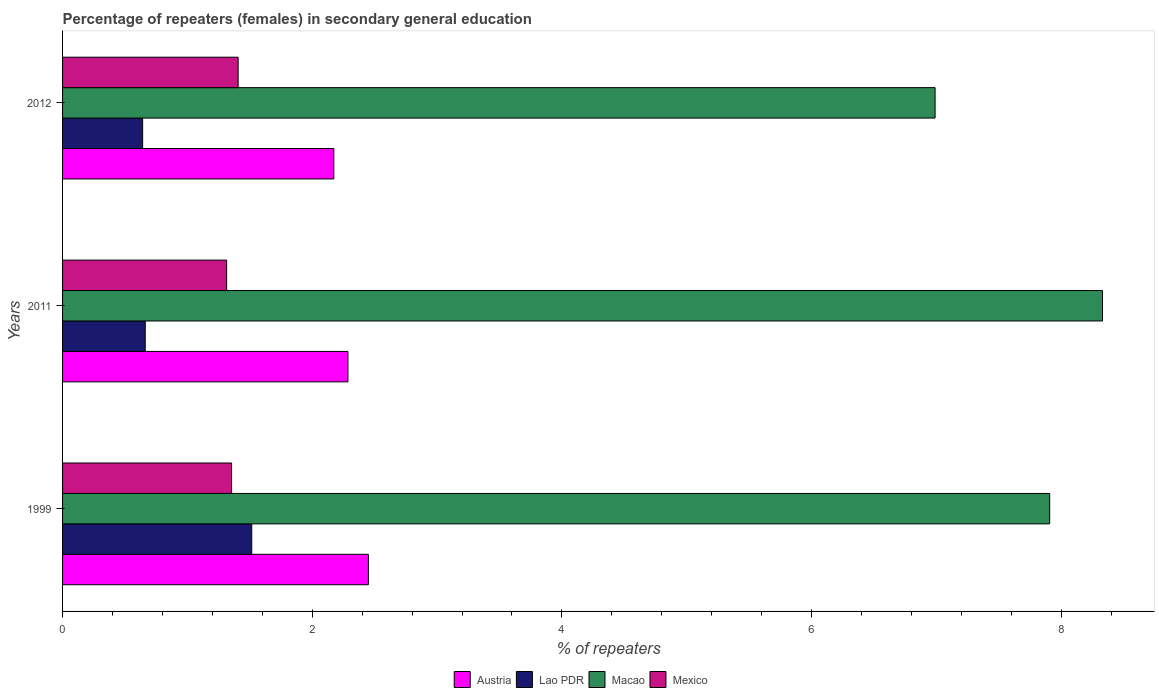How many groups of bars are there?
Offer a very short reply. 3. Are the number of bars per tick equal to the number of legend labels?
Your answer should be very brief. Yes. How many bars are there on the 1st tick from the bottom?
Ensure brevity in your answer.  4. In how many cases, is the number of bars for a given year not equal to the number of legend labels?
Provide a succinct answer. 0. What is the percentage of female repeaters in Macao in 2012?
Make the answer very short. 6.99. Across all years, what is the maximum percentage of female repeaters in Macao?
Provide a short and direct response. 8.33. Across all years, what is the minimum percentage of female repeaters in Mexico?
Your answer should be very brief. 1.31. What is the total percentage of female repeaters in Lao PDR in the graph?
Provide a short and direct response. 2.82. What is the difference between the percentage of female repeaters in Mexico in 1999 and that in 2012?
Make the answer very short. -0.05. What is the difference between the percentage of female repeaters in Austria in 1999 and the percentage of female repeaters in Lao PDR in 2012?
Ensure brevity in your answer.  1.81. What is the average percentage of female repeaters in Macao per year?
Your answer should be compact. 7.74. In the year 1999, what is the difference between the percentage of female repeaters in Lao PDR and percentage of female repeaters in Macao?
Your answer should be very brief. -6.39. In how many years, is the percentage of female repeaters in Mexico greater than 2.4 %?
Ensure brevity in your answer.  0. What is the ratio of the percentage of female repeaters in Mexico in 1999 to that in 2012?
Make the answer very short. 0.96. What is the difference between the highest and the second highest percentage of female repeaters in Lao PDR?
Offer a terse response. 0.85. What is the difference between the highest and the lowest percentage of female repeaters in Mexico?
Offer a terse response. 0.09. What does the 3rd bar from the bottom in 2012 represents?
Offer a very short reply. Macao. Is it the case that in every year, the sum of the percentage of female repeaters in Macao and percentage of female repeaters in Austria is greater than the percentage of female repeaters in Mexico?
Offer a terse response. Yes. How many bars are there?
Ensure brevity in your answer.  12. Are all the bars in the graph horizontal?
Your response must be concise. Yes. What is the difference between two consecutive major ticks on the X-axis?
Provide a succinct answer. 2. Does the graph contain any zero values?
Offer a very short reply. No. Where does the legend appear in the graph?
Your response must be concise. Bottom center. How many legend labels are there?
Your response must be concise. 4. How are the legend labels stacked?
Keep it short and to the point. Horizontal. What is the title of the graph?
Your answer should be very brief. Percentage of repeaters (females) in secondary general education. What is the label or title of the X-axis?
Provide a succinct answer. % of repeaters. What is the % of repeaters in Austria in 1999?
Ensure brevity in your answer.  2.45. What is the % of repeaters of Lao PDR in 1999?
Offer a very short reply. 1.52. What is the % of repeaters of Macao in 1999?
Provide a short and direct response. 7.91. What is the % of repeaters of Mexico in 1999?
Make the answer very short. 1.35. What is the % of repeaters in Austria in 2011?
Keep it short and to the point. 2.29. What is the % of repeaters in Lao PDR in 2011?
Ensure brevity in your answer.  0.66. What is the % of repeaters of Macao in 2011?
Provide a short and direct response. 8.33. What is the % of repeaters in Mexico in 2011?
Give a very brief answer. 1.31. What is the % of repeaters of Austria in 2012?
Provide a short and direct response. 2.17. What is the % of repeaters of Lao PDR in 2012?
Your response must be concise. 0.64. What is the % of repeaters of Macao in 2012?
Provide a short and direct response. 6.99. What is the % of repeaters in Mexico in 2012?
Your response must be concise. 1.41. Across all years, what is the maximum % of repeaters in Austria?
Your answer should be compact. 2.45. Across all years, what is the maximum % of repeaters of Lao PDR?
Your answer should be very brief. 1.52. Across all years, what is the maximum % of repeaters in Macao?
Your response must be concise. 8.33. Across all years, what is the maximum % of repeaters in Mexico?
Your answer should be compact. 1.41. Across all years, what is the minimum % of repeaters in Austria?
Make the answer very short. 2.17. Across all years, what is the minimum % of repeaters of Lao PDR?
Make the answer very short. 0.64. Across all years, what is the minimum % of repeaters of Macao?
Make the answer very short. 6.99. Across all years, what is the minimum % of repeaters of Mexico?
Make the answer very short. 1.31. What is the total % of repeaters in Austria in the graph?
Your answer should be compact. 6.91. What is the total % of repeaters of Lao PDR in the graph?
Offer a terse response. 2.82. What is the total % of repeaters in Macao in the graph?
Provide a short and direct response. 23.23. What is the total % of repeaters of Mexico in the graph?
Ensure brevity in your answer.  4.07. What is the difference between the % of repeaters in Austria in 1999 and that in 2011?
Offer a terse response. 0.16. What is the difference between the % of repeaters of Lao PDR in 1999 and that in 2011?
Offer a very short reply. 0.85. What is the difference between the % of repeaters in Macao in 1999 and that in 2011?
Keep it short and to the point. -0.42. What is the difference between the % of repeaters in Mexico in 1999 and that in 2011?
Give a very brief answer. 0.04. What is the difference between the % of repeaters in Austria in 1999 and that in 2012?
Keep it short and to the point. 0.28. What is the difference between the % of repeaters in Lao PDR in 1999 and that in 2012?
Make the answer very short. 0.87. What is the difference between the % of repeaters in Macao in 1999 and that in 2012?
Ensure brevity in your answer.  0.92. What is the difference between the % of repeaters in Mexico in 1999 and that in 2012?
Provide a short and direct response. -0.05. What is the difference between the % of repeaters in Austria in 2011 and that in 2012?
Offer a very short reply. 0.11. What is the difference between the % of repeaters in Lao PDR in 2011 and that in 2012?
Offer a very short reply. 0.02. What is the difference between the % of repeaters of Macao in 2011 and that in 2012?
Your response must be concise. 1.34. What is the difference between the % of repeaters in Mexico in 2011 and that in 2012?
Keep it short and to the point. -0.09. What is the difference between the % of repeaters in Austria in 1999 and the % of repeaters in Lao PDR in 2011?
Your answer should be compact. 1.79. What is the difference between the % of repeaters of Austria in 1999 and the % of repeaters of Macao in 2011?
Provide a succinct answer. -5.88. What is the difference between the % of repeaters in Austria in 1999 and the % of repeaters in Mexico in 2011?
Your response must be concise. 1.14. What is the difference between the % of repeaters of Lao PDR in 1999 and the % of repeaters of Macao in 2011?
Keep it short and to the point. -6.82. What is the difference between the % of repeaters in Lao PDR in 1999 and the % of repeaters in Mexico in 2011?
Keep it short and to the point. 0.2. What is the difference between the % of repeaters in Macao in 1999 and the % of repeaters in Mexico in 2011?
Your answer should be very brief. 6.59. What is the difference between the % of repeaters of Austria in 1999 and the % of repeaters of Lao PDR in 2012?
Your answer should be very brief. 1.81. What is the difference between the % of repeaters in Austria in 1999 and the % of repeaters in Macao in 2012?
Ensure brevity in your answer.  -4.54. What is the difference between the % of repeaters in Austria in 1999 and the % of repeaters in Mexico in 2012?
Your answer should be compact. 1.04. What is the difference between the % of repeaters in Lao PDR in 1999 and the % of repeaters in Macao in 2012?
Ensure brevity in your answer.  -5.47. What is the difference between the % of repeaters of Lao PDR in 1999 and the % of repeaters of Mexico in 2012?
Make the answer very short. 0.11. What is the difference between the % of repeaters in Macao in 1999 and the % of repeaters in Mexico in 2012?
Ensure brevity in your answer.  6.5. What is the difference between the % of repeaters in Austria in 2011 and the % of repeaters in Lao PDR in 2012?
Make the answer very short. 1.64. What is the difference between the % of repeaters of Austria in 2011 and the % of repeaters of Macao in 2012?
Make the answer very short. -4.7. What is the difference between the % of repeaters of Austria in 2011 and the % of repeaters of Mexico in 2012?
Provide a succinct answer. 0.88. What is the difference between the % of repeaters of Lao PDR in 2011 and the % of repeaters of Macao in 2012?
Ensure brevity in your answer.  -6.33. What is the difference between the % of repeaters in Lao PDR in 2011 and the % of repeaters in Mexico in 2012?
Provide a short and direct response. -0.74. What is the difference between the % of repeaters of Macao in 2011 and the % of repeaters of Mexico in 2012?
Provide a succinct answer. 6.92. What is the average % of repeaters in Austria per year?
Keep it short and to the point. 2.3. What is the average % of repeaters in Lao PDR per year?
Keep it short and to the point. 0.94. What is the average % of repeaters in Macao per year?
Your response must be concise. 7.74. What is the average % of repeaters of Mexico per year?
Ensure brevity in your answer.  1.36. In the year 1999, what is the difference between the % of repeaters in Austria and % of repeaters in Lao PDR?
Ensure brevity in your answer.  0.93. In the year 1999, what is the difference between the % of repeaters of Austria and % of repeaters of Macao?
Make the answer very short. -5.46. In the year 1999, what is the difference between the % of repeaters in Austria and % of repeaters in Mexico?
Your response must be concise. 1.1. In the year 1999, what is the difference between the % of repeaters of Lao PDR and % of repeaters of Macao?
Make the answer very short. -6.39. In the year 1999, what is the difference between the % of repeaters of Lao PDR and % of repeaters of Mexico?
Make the answer very short. 0.16. In the year 1999, what is the difference between the % of repeaters of Macao and % of repeaters of Mexico?
Ensure brevity in your answer.  6.55. In the year 2011, what is the difference between the % of repeaters in Austria and % of repeaters in Lao PDR?
Provide a succinct answer. 1.62. In the year 2011, what is the difference between the % of repeaters in Austria and % of repeaters in Macao?
Give a very brief answer. -6.04. In the year 2011, what is the difference between the % of repeaters of Austria and % of repeaters of Mexico?
Offer a very short reply. 0.97. In the year 2011, what is the difference between the % of repeaters of Lao PDR and % of repeaters of Macao?
Give a very brief answer. -7.67. In the year 2011, what is the difference between the % of repeaters of Lao PDR and % of repeaters of Mexico?
Make the answer very short. -0.65. In the year 2011, what is the difference between the % of repeaters in Macao and % of repeaters in Mexico?
Ensure brevity in your answer.  7.02. In the year 2012, what is the difference between the % of repeaters in Austria and % of repeaters in Lao PDR?
Offer a very short reply. 1.53. In the year 2012, what is the difference between the % of repeaters in Austria and % of repeaters in Macao?
Provide a succinct answer. -4.82. In the year 2012, what is the difference between the % of repeaters in Austria and % of repeaters in Mexico?
Provide a succinct answer. 0.77. In the year 2012, what is the difference between the % of repeaters of Lao PDR and % of repeaters of Macao?
Your response must be concise. -6.35. In the year 2012, what is the difference between the % of repeaters of Lao PDR and % of repeaters of Mexico?
Offer a terse response. -0.77. In the year 2012, what is the difference between the % of repeaters of Macao and % of repeaters of Mexico?
Provide a succinct answer. 5.58. What is the ratio of the % of repeaters of Austria in 1999 to that in 2011?
Your answer should be very brief. 1.07. What is the ratio of the % of repeaters of Lao PDR in 1999 to that in 2011?
Keep it short and to the point. 2.29. What is the ratio of the % of repeaters of Macao in 1999 to that in 2011?
Keep it short and to the point. 0.95. What is the ratio of the % of repeaters in Mexico in 1999 to that in 2011?
Ensure brevity in your answer.  1.03. What is the ratio of the % of repeaters of Austria in 1999 to that in 2012?
Offer a very short reply. 1.13. What is the ratio of the % of repeaters of Lao PDR in 1999 to that in 2012?
Keep it short and to the point. 2.36. What is the ratio of the % of repeaters in Macao in 1999 to that in 2012?
Provide a short and direct response. 1.13. What is the ratio of the % of repeaters in Mexico in 1999 to that in 2012?
Offer a terse response. 0.96. What is the ratio of the % of repeaters of Austria in 2011 to that in 2012?
Your response must be concise. 1.05. What is the ratio of the % of repeaters of Lao PDR in 2011 to that in 2012?
Your answer should be compact. 1.03. What is the ratio of the % of repeaters of Macao in 2011 to that in 2012?
Your response must be concise. 1.19. What is the ratio of the % of repeaters in Mexico in 2011 to that in 2012?
Make the answer very short. 0.93. What is the difference between the highest and the second highest % of repeaters of Austria?
Keep it short and to the point. 0.16. What is the difference between the highest and the second highest % of repeaters of Lao PDR?
Provide a succinct answer. 0.85. What is the difference between the highest and the second highest % of repeaters in Macao?
Your answer should be compact. 0.42. What is the difference between the highest and the second highest % of repeaters in Mexico?
Provide a short and direct response. 0.05. What is the difference between the highest and the lowest % of repeaters of Austria?
Make the answer very short. 0.28. What is the difference between the highest and the lowest % of repeaters in Lao PDR?
Ensure brevity in your answer.  0.87. What is the difference between the highest and the lowest % of repeaters in Macao?
Keep it short and to the point. 1.34. What is the difference between the highest and the lowest % of repeaters in Mexico?
Provide a short and direct response. 0.09. 